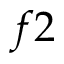<formula> <loc_0><loc_0><loc_500><loc_500>f 2</formula> 